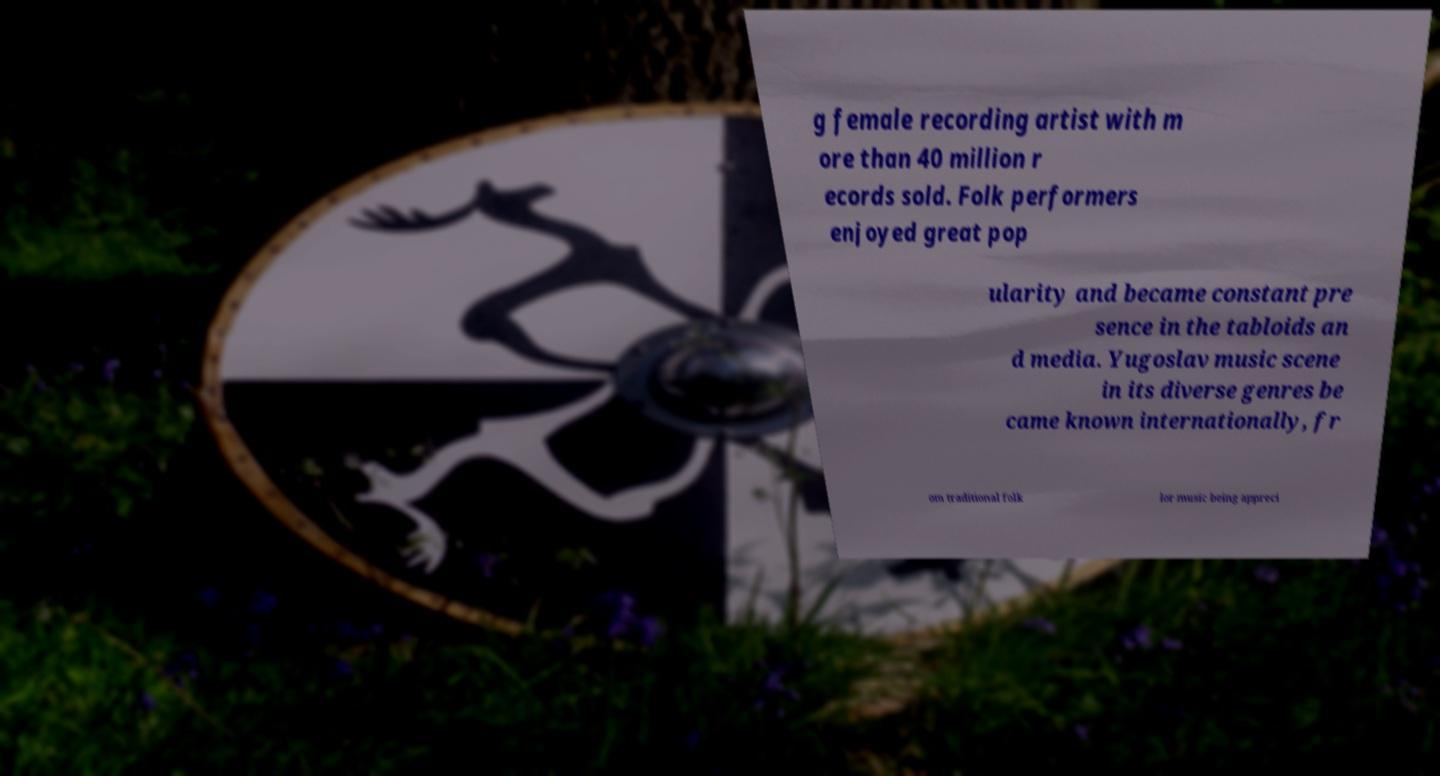Could you assist in decoding the text presented in this image and type it out clearly? g female recording artist with m ore than 40 million r ecords sold. Folk performers enjoyed great pop ularity and became constant pre sence in the tabloids an d media. Yugoslav music scene in its diverse genres be came known internationally, fr om traditional folk lor music being appreci 